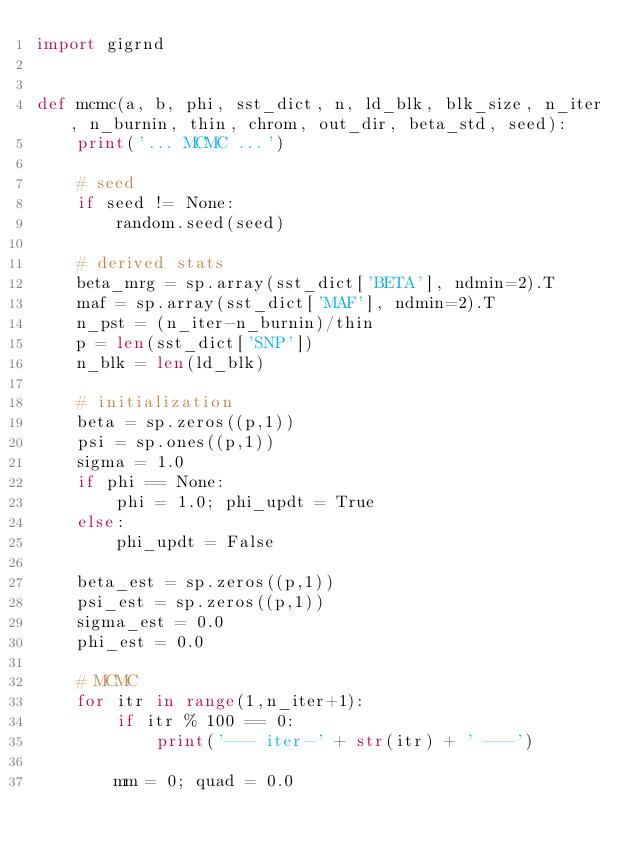Convert code to text. <code><loc_0><loc_0><loc_500><loc_500><_Python_>import gigrnd


def mcmc(a, b, phi, sst_dict, n, ld_blk, blk_size, n_iter, n_burnin, thin, chrom, out_dir, beta_std, seed):
    print('... MCMC ...')

    # seed
    if seed != None:
        random.seed(seed)

    # derived stats
    beta_mrg = sp.array(sst_dict['BETA'], ndmin=2).T
    maf = sp.array(sst_dict['MAF'], ndmin=2).T
    n_pst = (n_iter-n_burnin)/thin
    p = len(sst_dict['SNP'])
    n_blk = len(ld_blk)

    # initialization
    beta = sp.zeros((p,1))
    psi = sp.ones((p,1))
    sigma = 1.0
    if phi == None:
        phi = 1.0; phi_updt = True
    else:
        phi_updt = False

    beta_est = sp.zeros((p,1))
    psi_est = sp.zeros((p,1))
    sigma_est = 0.0
    phi_est = 0.0

    # MCMC
    for itr in range(1,n_iter+1):
        if itr % 100 == 0:
            print('--- iter-' + str(itr) + ' ---')

        mm = 0; quad = 0.0</code> 